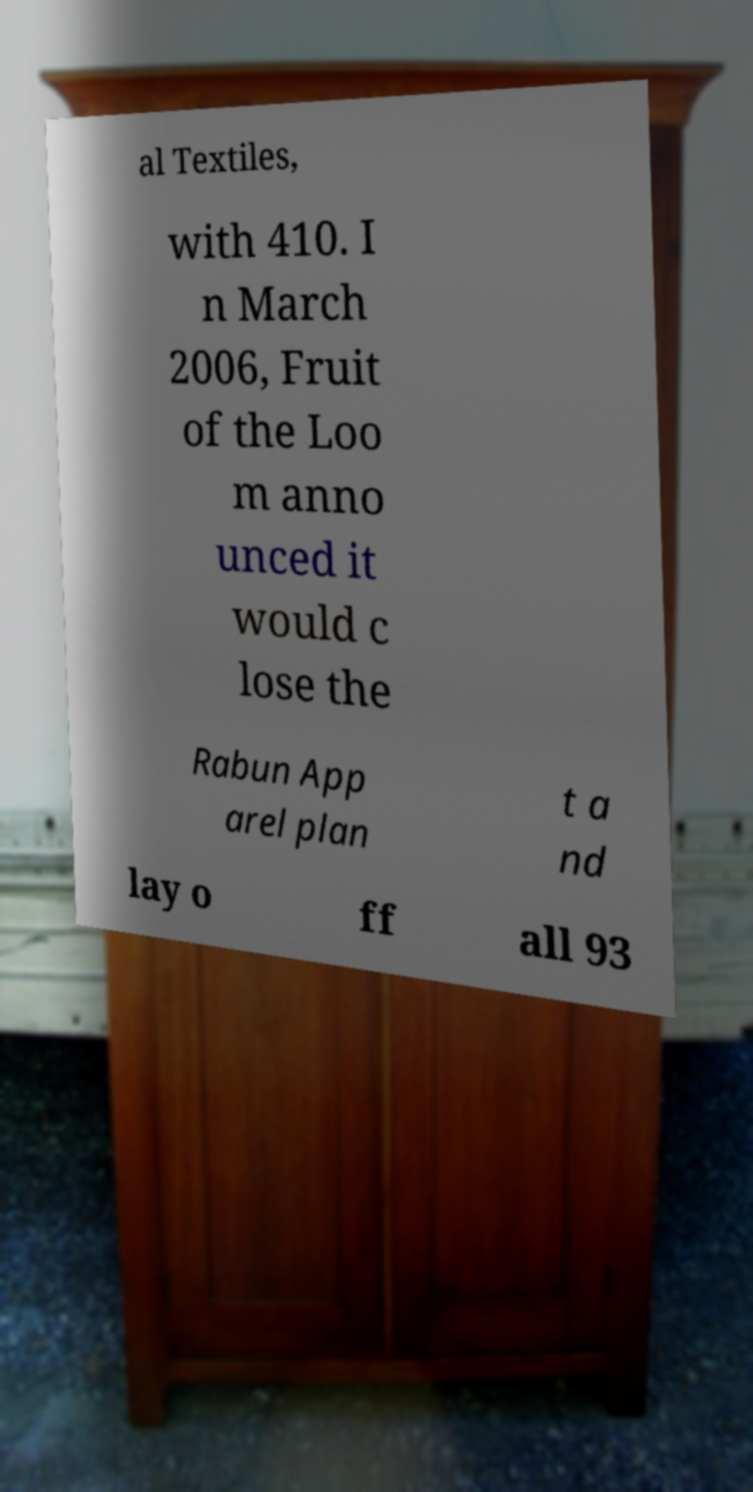What messages or text are displayed in this image? I need them in a readable, typed format. al Textiles, with 410. I n March 2006, Fruit of the Loo m anno unced it would c lose the Rabun App arel plan t a nd lay o ff all 93 